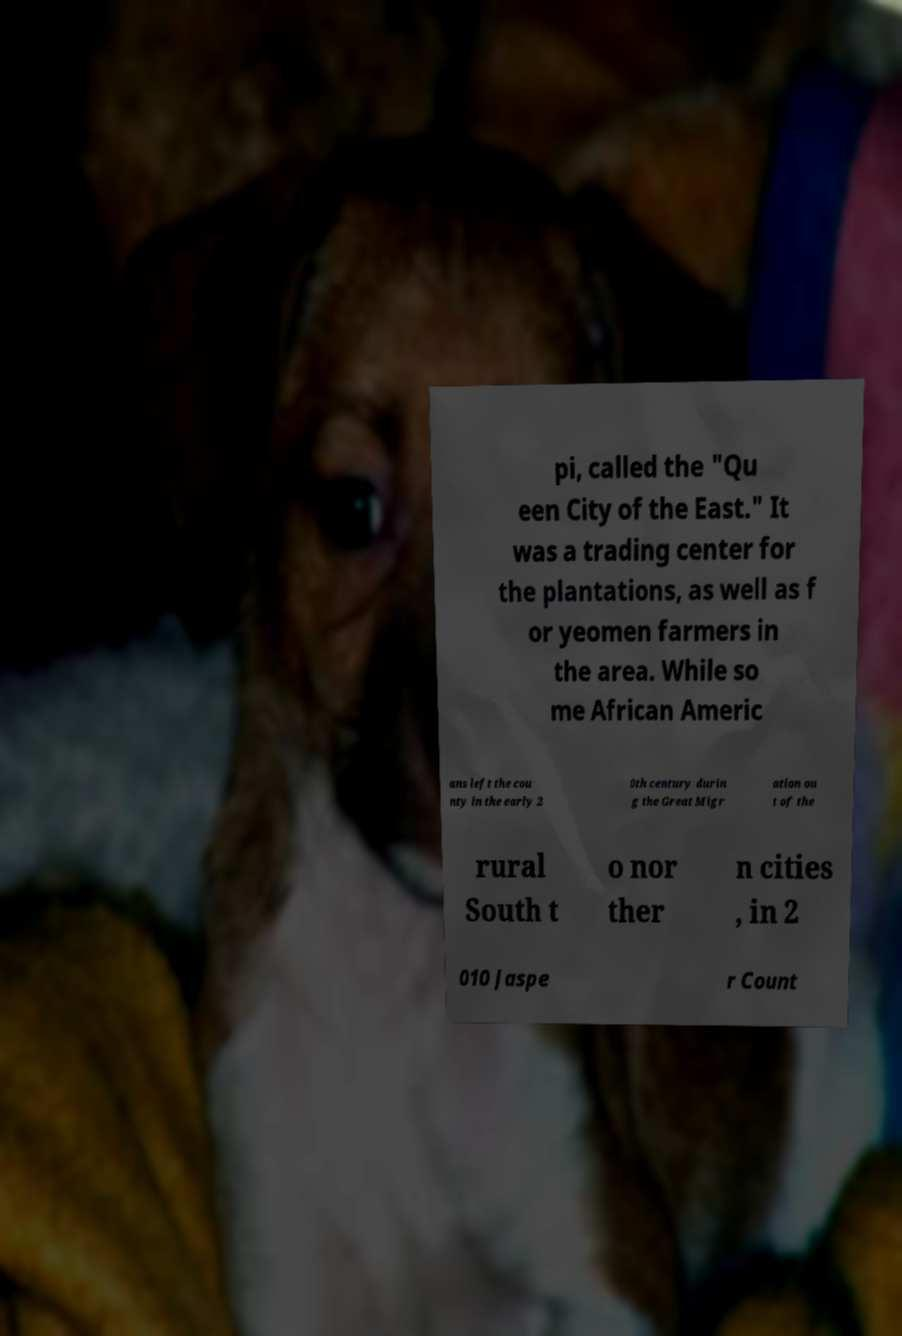Could you extract and type out the text from this image? pi, called the "Qu een City of the East." It was a trading center for the plantations, as well as f or yeomen farmers in the area. While so me African Americ ans left the cou nty in the early 2 0th century durin g the Great Migr ation ou t of the rural South t o nor ther n cities , in 2 010 Jaspe r Count 